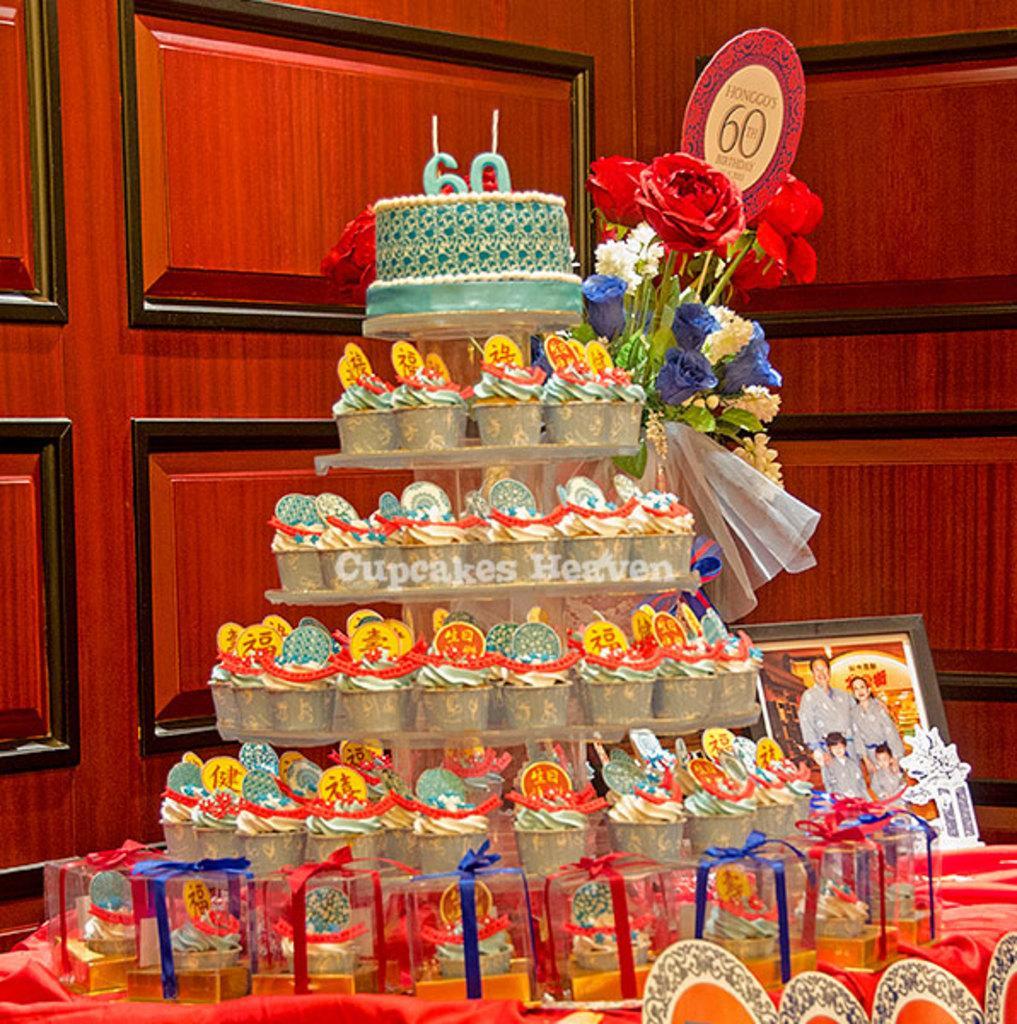Can you describe this image briefly? In the foreground of this picture, there are cup cakes in the stand, few more cupcakes on the table, a photo frame, a cake, flower vase. In the background, there is a red colored wall. 